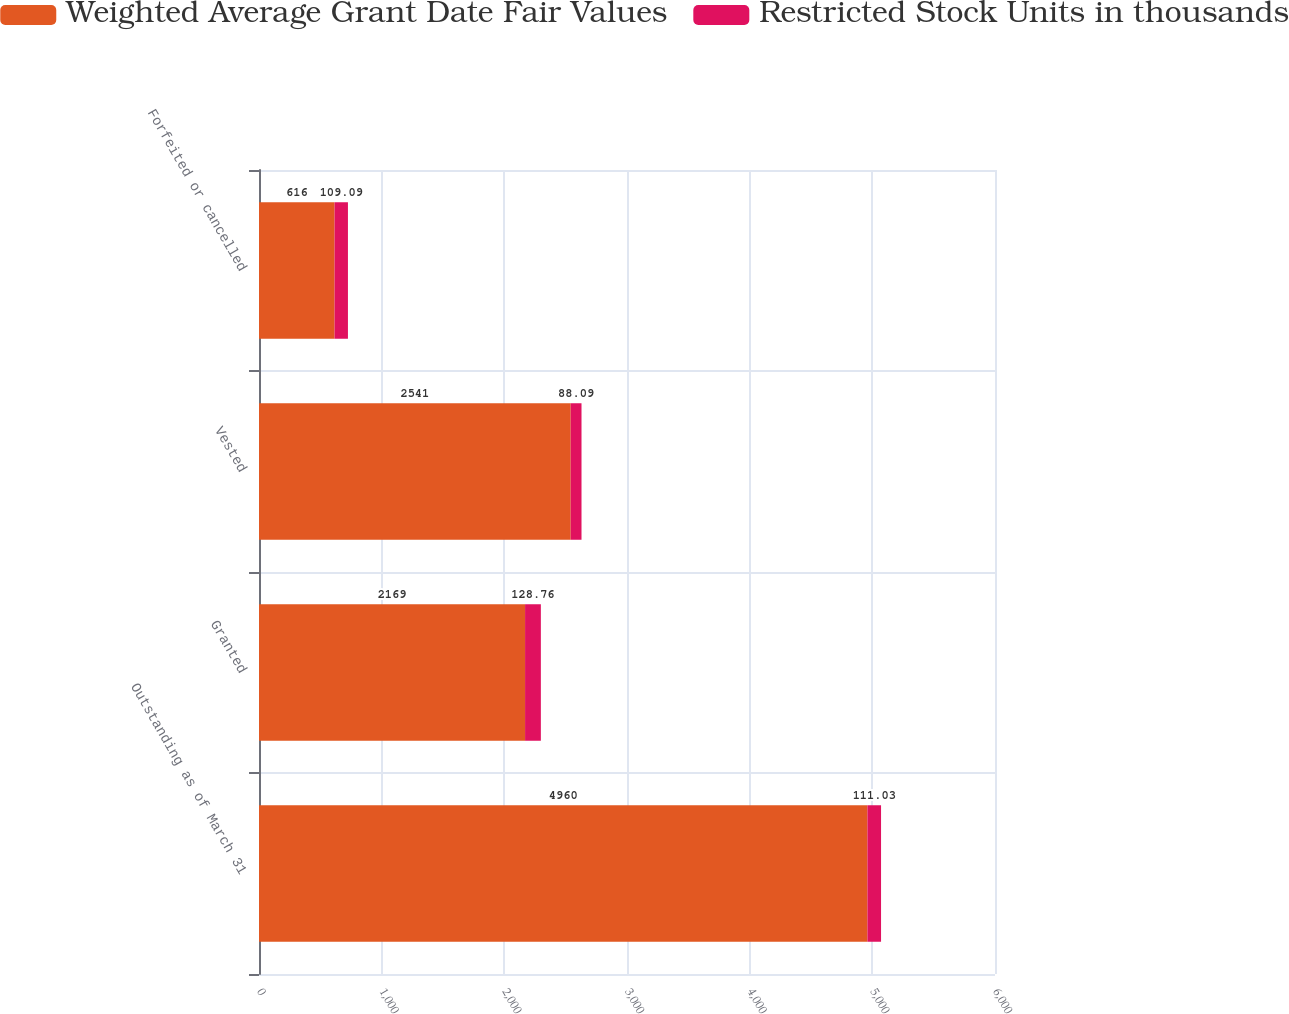<chart> <loc_0><loc_0><loc_500><loc_500><stacked_bar_chart><ecel><fcel>Outstanding as of March 31<fcel>Granted<fcel>Vested<fcel>Forfeited or cancelled<nl><fcel>Weighted Average Grant Date Fair Values<fcel>4960<fcel>2169<fcel>2541<fcel>616<nl><fcel>Restricted Stock Units in thousands<fcel>111.03<fcel>128.76<fcel>88.09<fcel>109.09<nl></chart> 